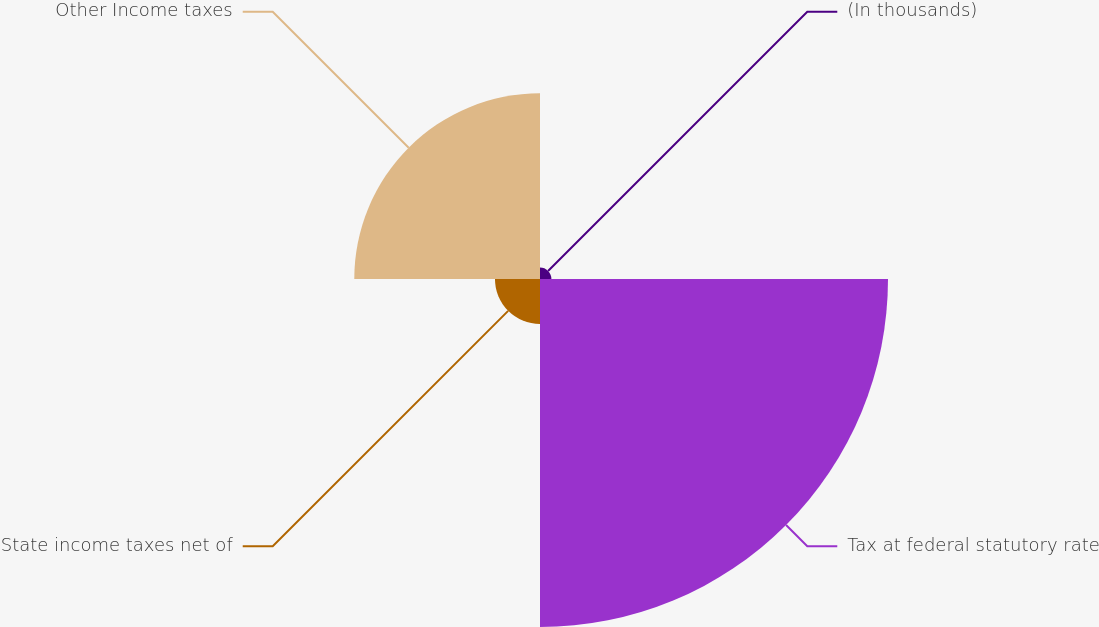Convert chart to OTSL. <chart><loc_0><loc_0><loc_500><loc_500><pie_chart><fcel>(In thousands)<fcel>Tax at federal statutory rate<fcel>State income taxes net of<fcel>Other Income taxes<nl><fcel>1.93%<fcel>58.97%<fcel>7.63%<fcel>31.47%<nl></chart> 